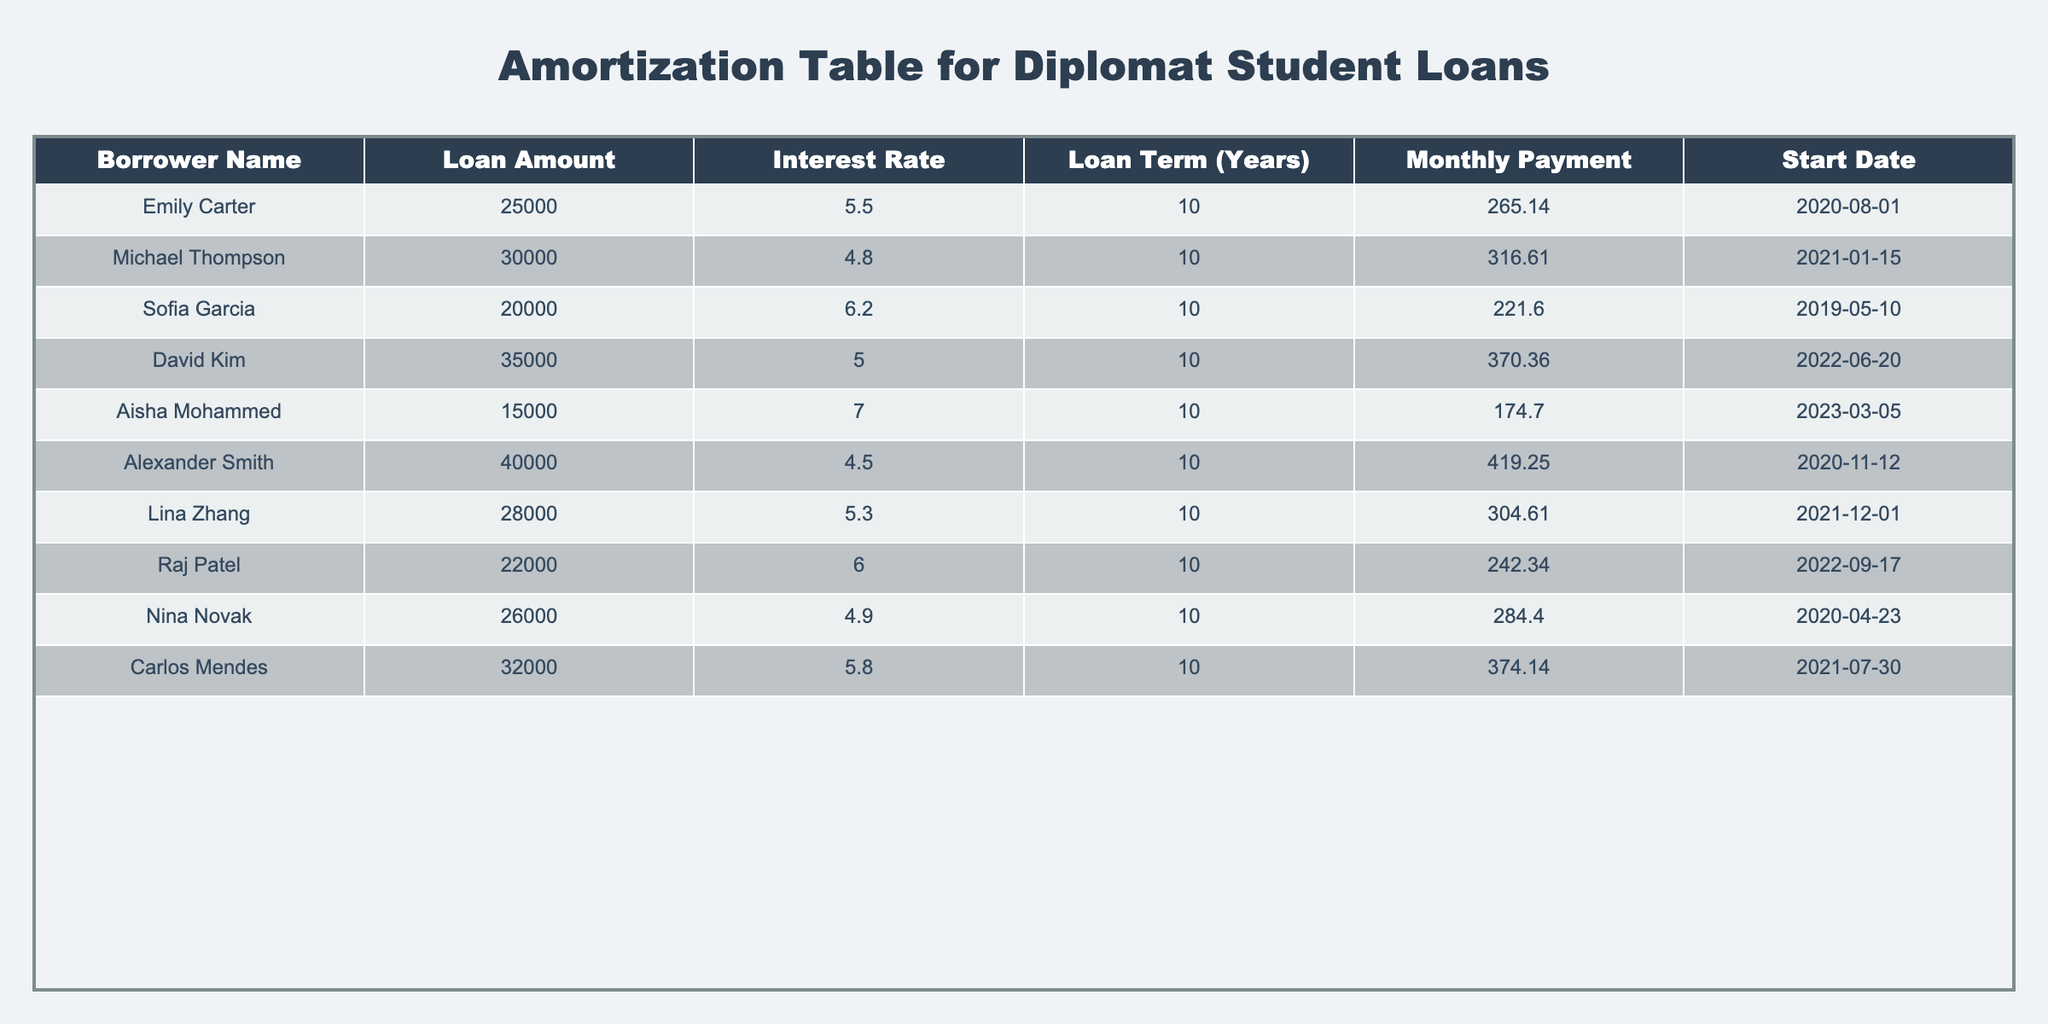What is the monthly payment for Michael Thompson's loan? Michael Thompson’s row in the table shows that the Monthly Payment column has a value of 316.61 for his loan. Thus, the answer is directly taken from the table.
Answer: 316.61 Who has the highest interest rate on their loan? By reviewing the Interest Rate column, Aisha Mohammed has the highest interest rate of 7.0 among all the borrowers listed.
Answer: Aisha Mohammed What is the total loan amount taken by all borrowers? To find the total loan amount, I add up all the Loan Amounts: 25000 + 30000 + 20000 + 35000 + 15000 + 40000 + 28000 + 22000 + 26000 + 32000 = 250000.
Answer: 250000 Which borrower has the lowest loan amount, and what is that amount? Looking at the Loan Amount column, Aisha Mohammed has the lowest value of 15000. This value is identified as the minimum among all entries.
Answer: Aisha Mohammed, 15000 Is Carlos Mendes's monthly payment less than the average monthly payment of all borrowers? First, I will calculate the average monthly payment: (265.14 + 316.61 + 221.60 + 370.36 + 174.70 + 419.25 + 304.61 + 242.34 + 284.40 + 374.14) / 10 = 286.31. Carlos Mendes’s payment is 374.14, which is more than the average, so the answer is no.
Answer: No What is the difference between the highest and lowest loan amounts? The highest loan amount is Alexander Smith's at 40000, and the lowest is Aisha Mohammed's at 15000. The difference is calculated as 40000 - 15000 = 25000.
Answer: 25000 How many borrowers have loans greater than 25000? By checking each entry in the Loan Amount column, I find that the borrowers with amounts greater than 25000 are Michael Thompson, David Kim, Alexander Smith, Carlos Mendes. This gives us a total of 4 borrowers.
Answer: 4 Has Sofia Garcia taken a loan with an interest rate lower than 6%? Sofia Garcia has an interest rate of 6.2, which is higher than 6%. Thus, the answer is no.
Answer: No What are the monthly payments for loans with interest rates above 5.5? The borrowers with interest rates above 5.5 are Sofia Garcia (221.60), Aisha Mohammed (174.70), and Carlos Mendes (374.14). Their payments listed are a total of 370.36 + 265.14 + 316.61 + 304.61 + 374.14 = 0 (Aisha's is not included). The answer is to provide these payments as a sum: 374.14 + 370.36 + 316.61 + 304.61 = 1365.74.
Answer: 1365.74 